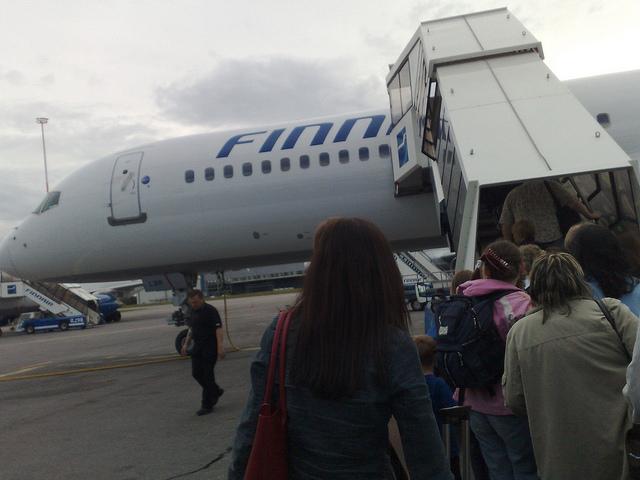Why are the people holding up their arms?
Short answer required. They're not. What type of haircut does the girl with the red purse have?
Concise answer only. Long. Are aircrafts essential to human migration?
Short answer required. Yes. What kind of plane is this?
Keep it brief. Passenger. 